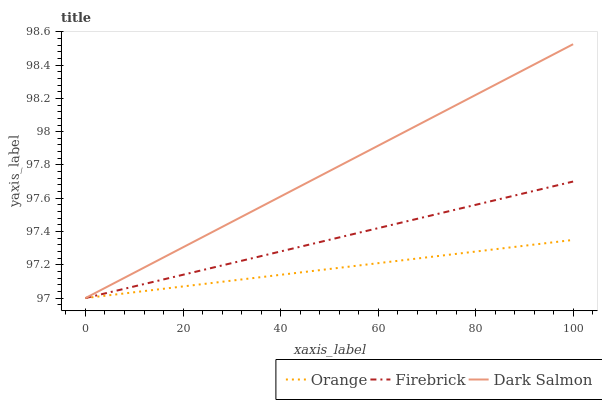Does Firebrick have the minimum area under the curve?
Answer yes or no. No. Does Firebrick have the maximum area under the curve?
Answer yes or no. No. Is Firebrick the smoothest?
Answer yes or no. No. Is Firebrick the roughest?
Answer yes or no. No. Does Firebrick have the highest value?
Answer yes or no. No. 